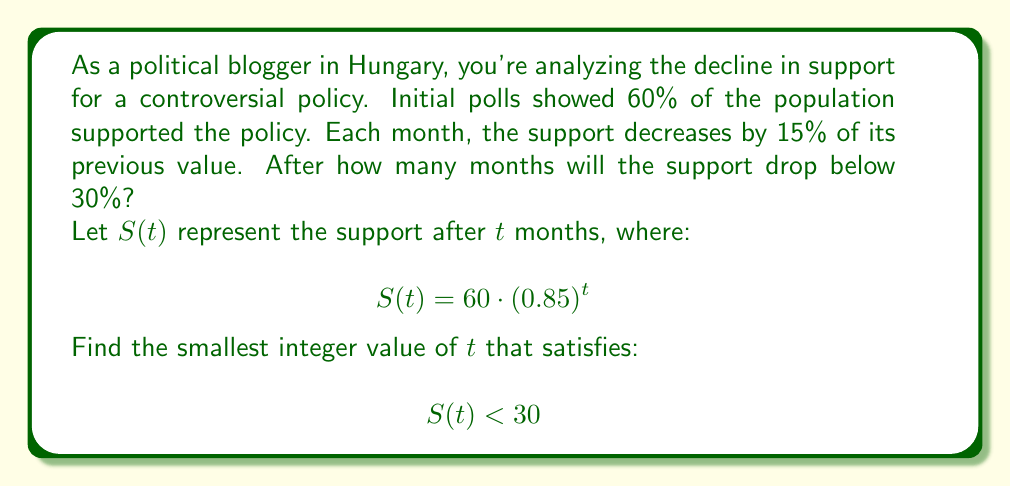Could you help me with this problem? To solve this problem, we need to use the properties of exponential decay and logarithms:

1) We start with the inequality:
   $$60 \cdot (0.85)^t < 30$$

2) Divide both sides by 60:
   $$(0.85)^t < \frac{1}{2}$$

3) Take the natural logarithm of both sides:
   $$t \cdot \ln(0.85) < \ln(\frac{1}{2})$$

4) Divide both sides by $\ln(0.85)$ (note that $\ln(0.85)$ is negative, so the inequality sign flips):
   $$t > \frac{\ln(\frac{1}{2})}{\ln(0.85)}$$

5) Calculate the right-hand side:
   $$t > \frac{\ln(0.5)}{\ln(0.85)} \approx 4.2735$$

6) Since we need the smallest integer value of $t$, we round up to the next whole number:
   $$t = 5$$

We can verify:
$$60 \cdot (0.85)^4 \approx 31.19 > 30$$
$$60 \cdot (0.85)^5 \approx 26.51 < 30$$
Answer: The support for the policy will drop below 30% after 5 months. 